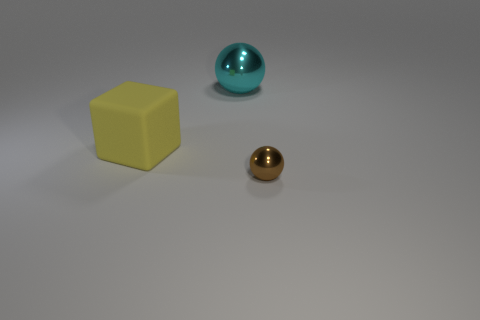What might be the sizes of these objects relative to each other? Visually, the yellow cube appears smallest in size, the gold sphere is slightly larger, and the turquoise sphere is the largest of the three objects. Is there a way to determine their exact sizes? Without additional context, measuring tools, or references in the image, we can't determine the exact sizes. However, the relative sizes are inferred from their visual proportions in relation to one another. 